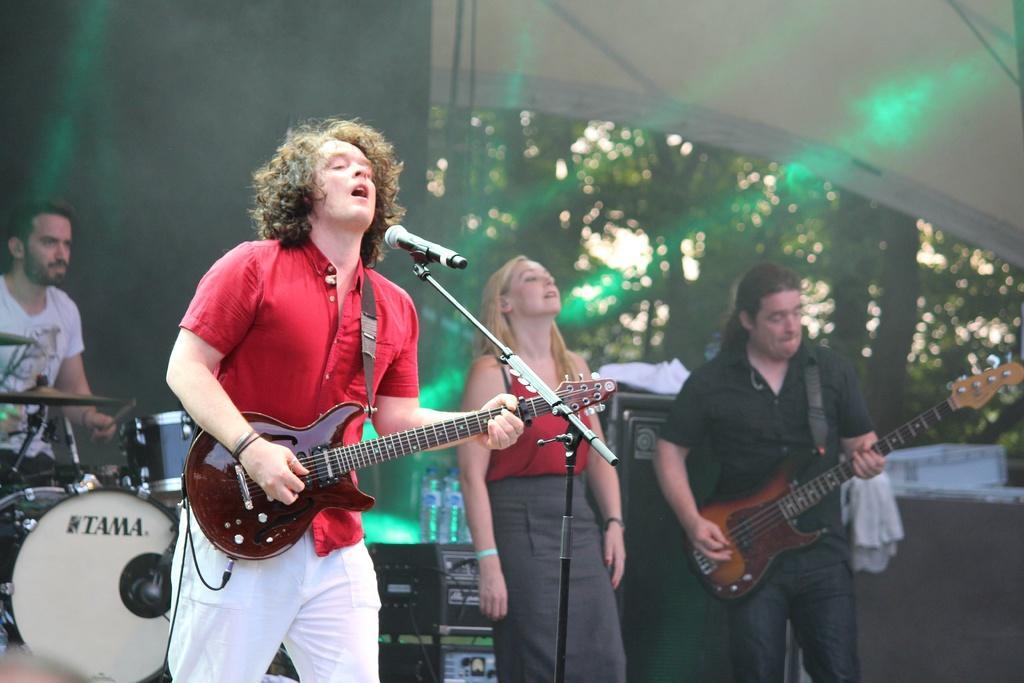Please provide a concise description of this image. Here we can see a group of people are standing and holding a guitar in his hands, and in front here is the microphone, and at back here are the musical drums, and here is the tree. 